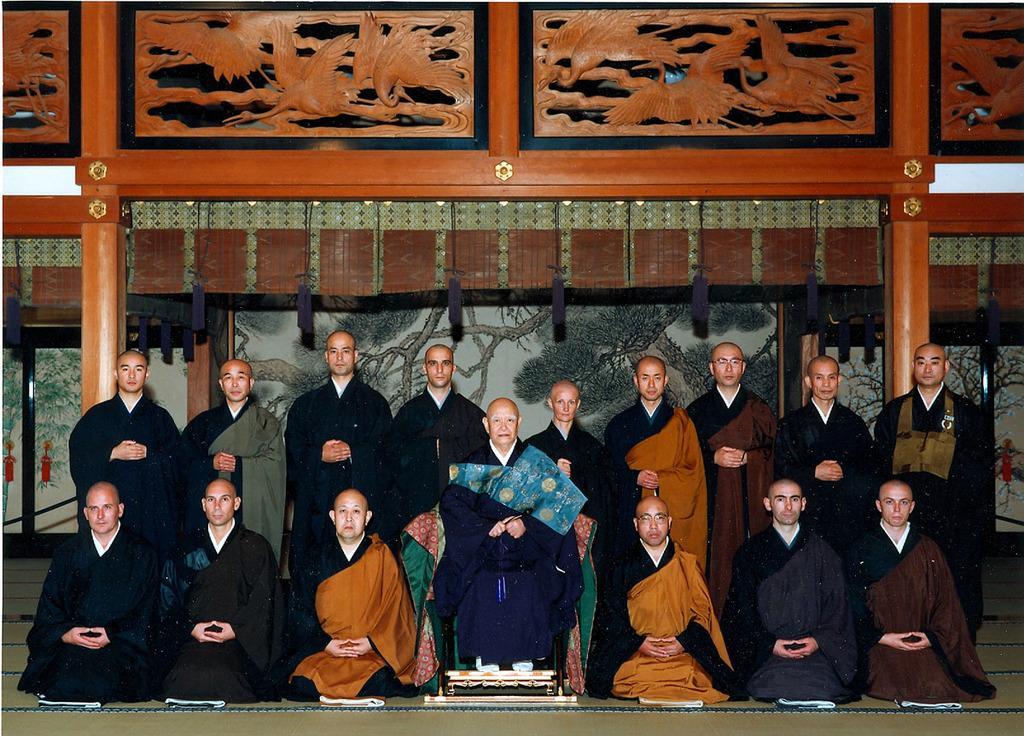How would you summarize this image in a sentence or two? Here we can see people. This person is sitting on a chair. Background there is a wall. Painting is on the wall. These are wooden carved designs. 